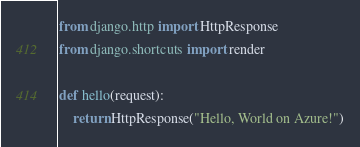<code> <loc_0><loc_0><loc_500><loc_500><_Python_>from django.http import HttpResponse
from django.shortcuts import render

def hello(request):
    return HttpResponse("Hello, World on Azure!")
</code> 